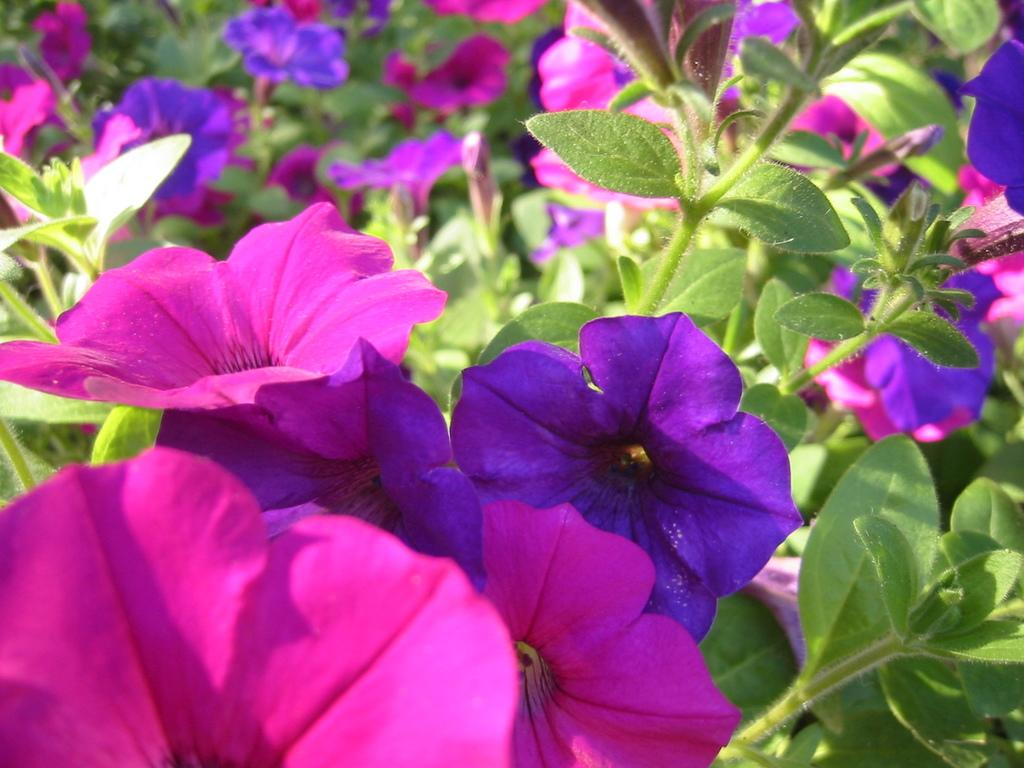Where was the image taken? The image was taken outdoors. What can be seen in the image besides the outdoor setting? There are many plants in the image. What is special about the plants in the image? The plants have beautiful flowers. What colors are the flowers in the image? The flowers are purple and pink in color. What time of day is the creator of the flowers shown in the image? The image does not depict the creator of the flowers, so it is not possible to determine the time of day they are shown. 